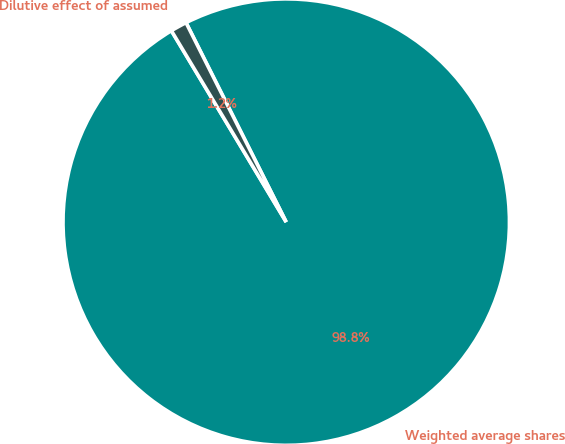<chart> <loc_0><loc_0><loc_500><loc_500><pie_chart><fcel>Weighted average shares<fcel>Dilutive effect of assumed<nl><fcel>98.81%<fcel>1.19%<nl></chart> 